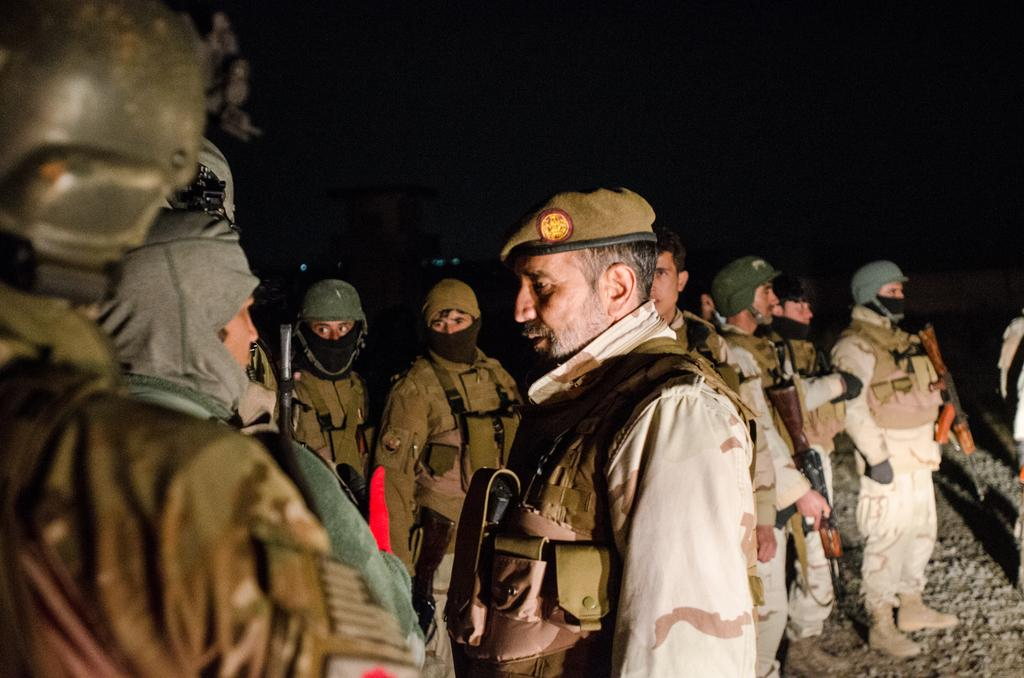How many persons are visible in the image? There are persons standing in the image. Where are some of the persons located in the image? Some of the persons are standing in the middle of the image. Can you describe the position of the person on the right side of the image? At least one person is standing on the right side of the image, and they are holding a weapon. What is the condition of the grandmother's house in the image? There is no mention of a grandmother or a house in the image, so we cannot determine the condition of any house. 